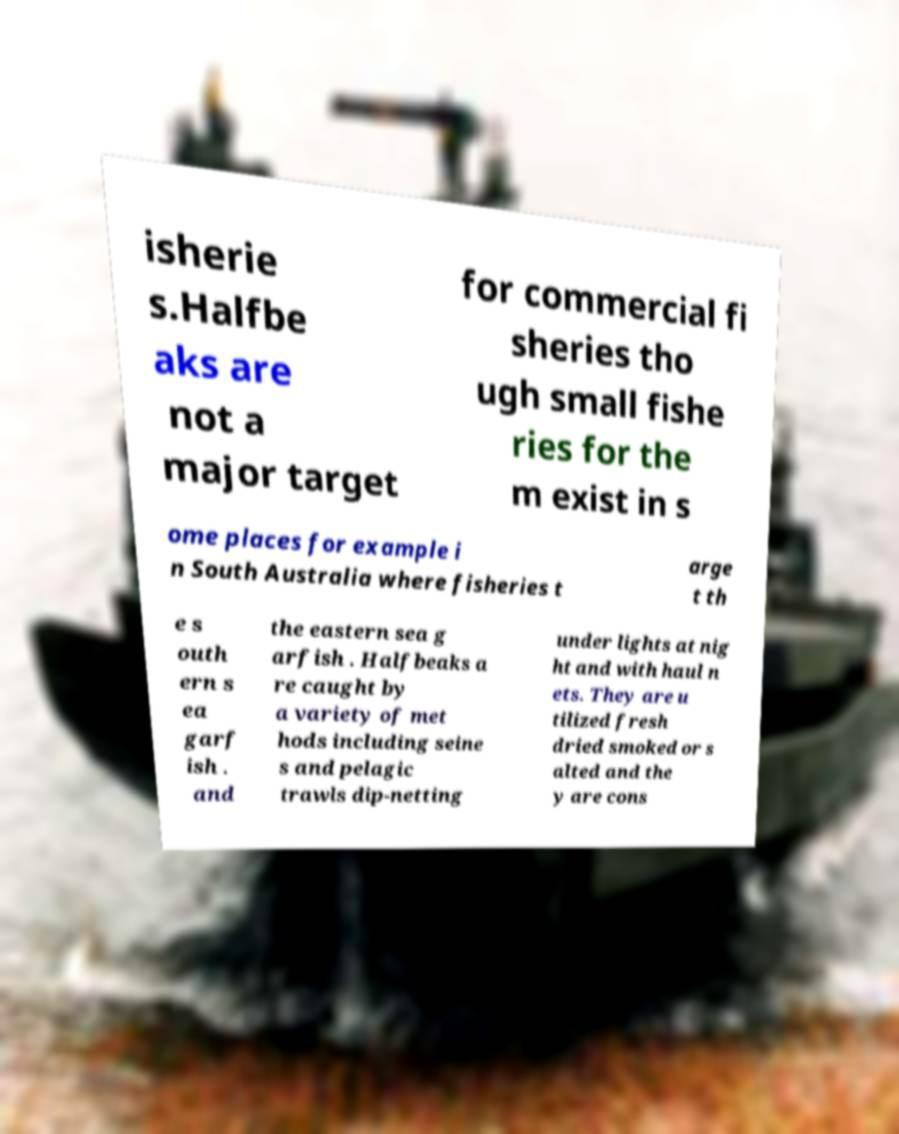Can you accurately transcribe the text from the provided image for me? isherie s.Halfbe aks are not a major target for commercial fi sheries tho ugh small fishe ries for the m exist in s ome places for example i n South Australia where fisheries t arge t th e s outh ern s ea garf ish . and the eastern sea g arfish . Halfbeaks a re caught by a variety of met hods including seine s and pelagic trawls dip-netting under lights at nig ht and with haul n ets. They are u tilized fresh dried smoked or s alted and the y are cons 